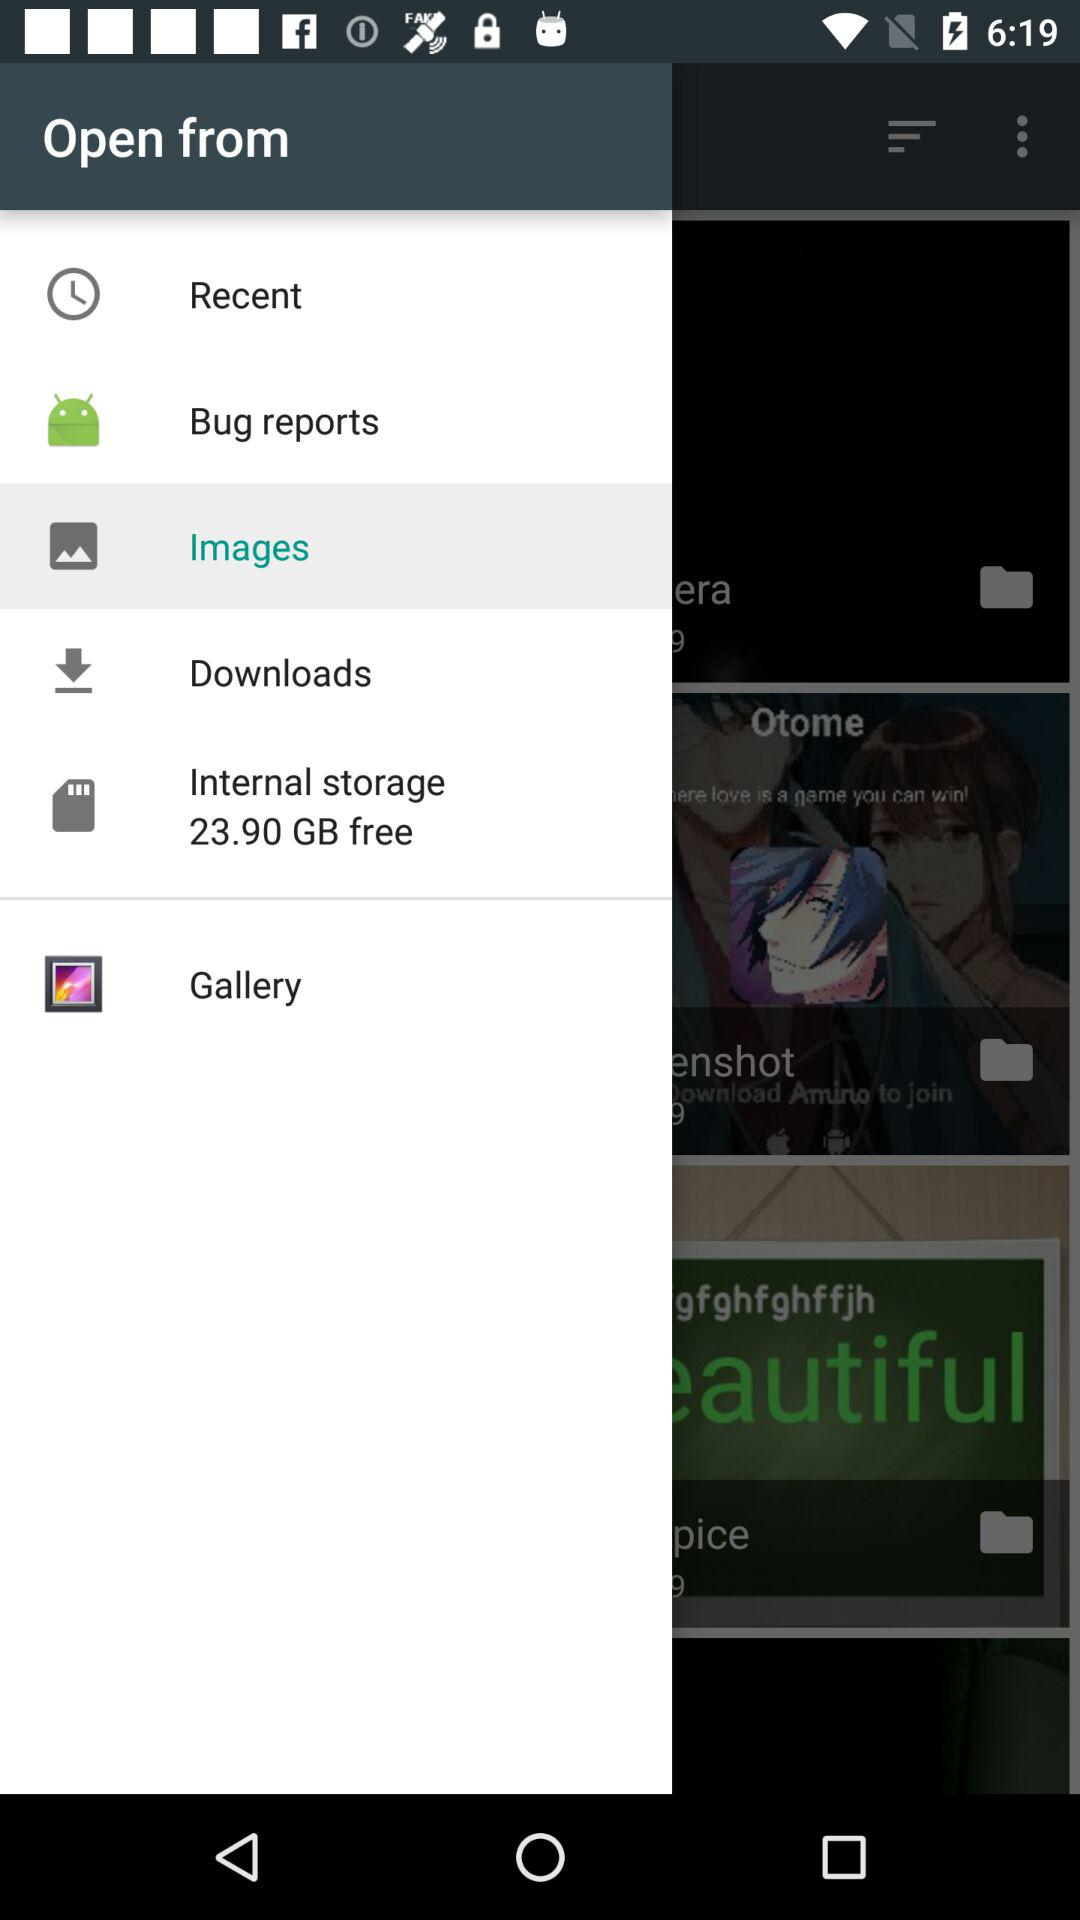What option is selected? The selected option is "Images". 